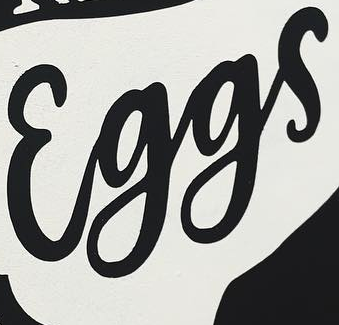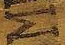What text is displayed in these images sequentially, separated by a semicolon? Eggs; M 